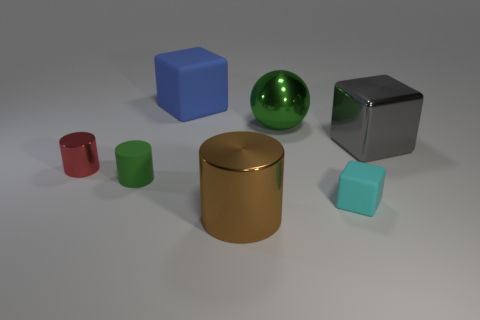The rubber cylinder that is the same color as the big metal ball is what size?
Provide a succinct answer. Small. Are there fewer tiny matte cylinders behind the large blue cube than cyan cylinders?
Provide a succinct answer. No. Is the small green thing in front of the green shiny object made of the same material as the brown thing?
Provide a short and direct response. No. There is a object that is in front of the rubber block that is on the right side of the cylinder that is on the right side of the large blue cube; what is its shape?
Give a very brief answer. Cylinder. Is there a green thing that has the same size as the gray object?
Your answer should be compact. Yes. What is the size of the blue block?
Make the answer very short. Large. How many metal things have the same size as the shiny cube?
Provide a short and direct response. 2. Is the number of green metallic things on the left side of the red metallic cylinder less than the number of big cubes that are on the left side of the cyan block?
Your answer should be very brief. Yes. There is a rubber cube to the left of the metallic object in front of the small cylinder in front of the red metallic thing; how big is it?
Offer a terse response. Large. What is the size of the thing that is to the left of the brown cylinder and behind the large gray block?
Provide a succinct answer. Large. 